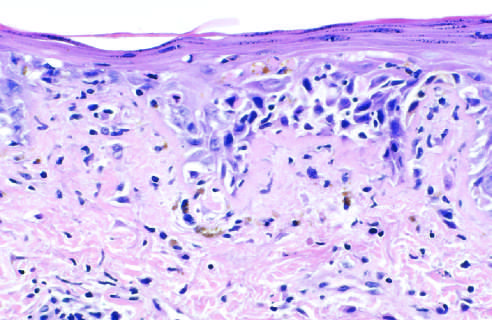what shows liquefactive degeneration of the basal layer of the epidermis and edema at the dermoepidermal junction?
Answer the question using a single word or phrase. An h&e-stained section 